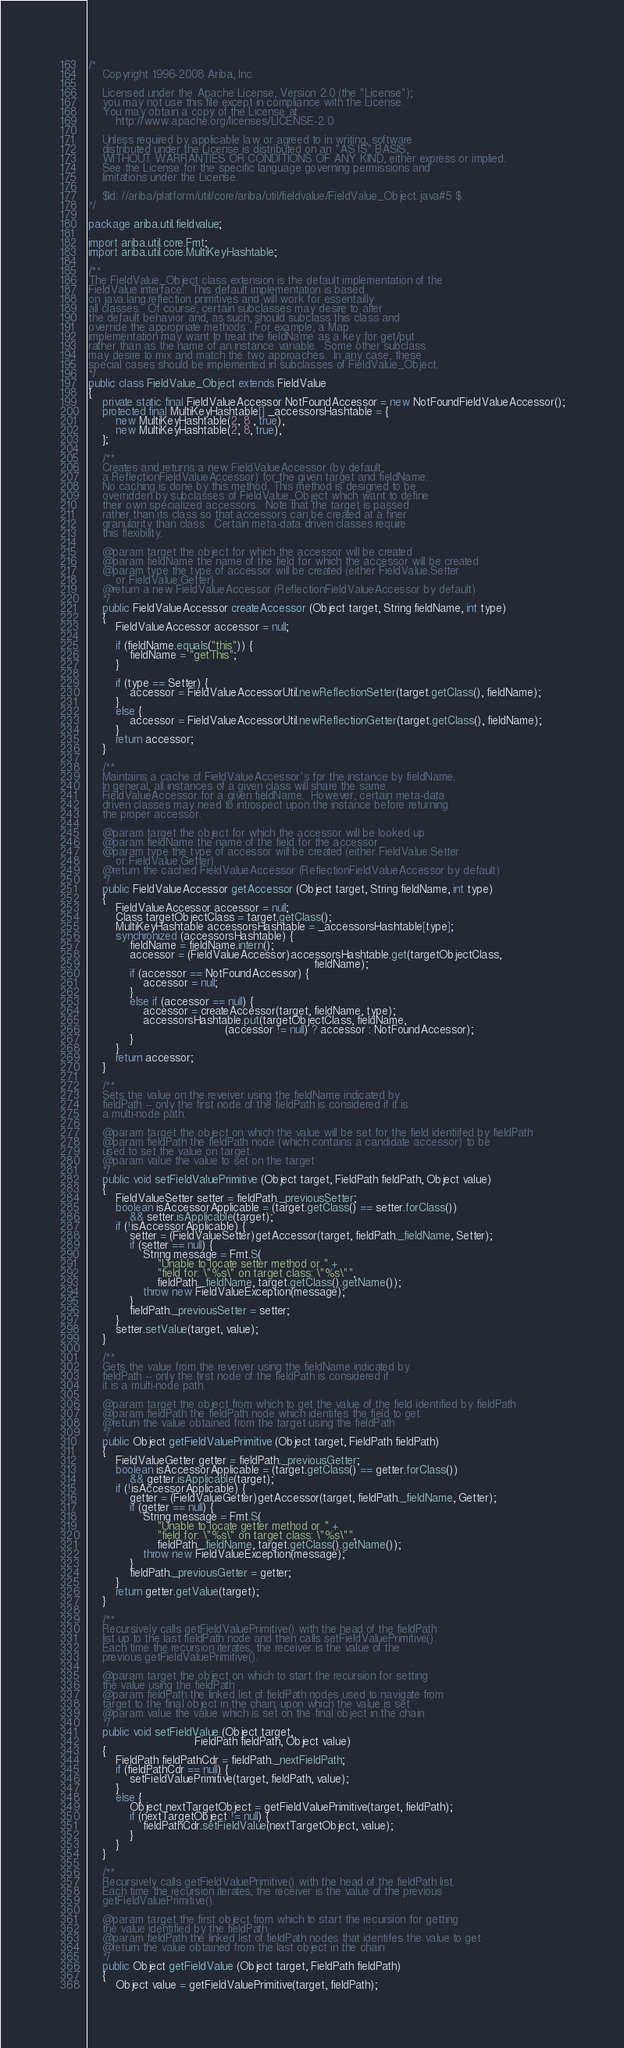<code> <loc_0><loc_0><loc_500><loc_500><_Java_>/*
    Copyright 1996-2008 Ariba, Inc.

    Licensed under the Apache License, Version 2.0 (the "License");
    you may not use this file except in compliance with the License.
    You may obtain a copy of the License at
        http://www.apache.org/licenses/LICENSE-2.0

    Unless required by applicable law or agreed to in writing, software
    distributed under the License is distributed on an "AS IS" BASIS,
    WITHOUT WARRANTIES OR CONDITIONS OF ANY KIND, either express or implied.
    See the License for the specific language governing permissions and
    limitations under the License.

    $Id: //ariba/platform/util/core/ariba/util/fieldvalue/FieldValue_Object.java#5 $
*/

package ariba.util.fieldvalue;

import ariba.util.core.Fmt;
import ariba.util.core.MultiKeyHashtable;

/**
The FieldValue_Object class extension is the default implementation of the
FieldValue interface.  This default implementation is based
on java.lang.reflection primitives and will work for essentailly
all classes.  Of course, certain subclasses may desire to alter
the default behavior and, as such, should subclass this class and
override the appropriate methods.  For example, a Map
implementation may want to treat the fieldName as a key for get/put
rather than as the name of an instance variable.  Some other subclass
may desire to mix and match the two approaches.  In any case, these
special cases should be implemented in subclasses of FieldValue_Object.
*/
public class FieldValue_Object extends FieldValue
{
    private static final FieldValueAccessor NotFoundAccessor = new NotFoundFieldValueAccessor();
    protected final MultiKeyHashtable[] _accessorsHashtable = {
        new MultiKeyHashtable(2, 8 , true),
        new MultiKeyHashtable(2, 8, true),
    };

    /**
    Creates and returns a new FieldValueAccessor (by default,
    a ReflectionFieldValueAccessor) for the given target and fieldName.
    No caching is done by this method. This method is designed to be
    overridden by subclasses of FieldValue_Object which want to define
    their own specialized accessors.  Note that the target is passed
    rather than its class so that accessors can be created at a finer
    granularity than class.  Certain meta-data driven classes require
    this flexibility.

    @param target the object for which the accessor will be created
    @param fieldName the name of the field for which the accessor will be created
    @param type the type of accessor will be created (either FieldValue.Setter
        or FieldValue.Getter)
    @return a new FieldValueAccessor (ReflectionFieldValueAccessor by default)
    */
    public FieldValueAccessor createAccessor (Object target, String fieldName, int type)
    {
        FieldValueAccessor accessor = null;

        if (fieldName.equals("this")) {
            fieldName = "getThis";
        }

        if (type == Setter) {
            accessor = FieldValueAccessorUtil.newReflectionSetter(target.getClass(), fieldName);
        }
        else {
            accessor = FieldValueAccessorUtil.newReflectionGetter(target.getClass(), fieldName);
        }
        return accessor;
    }

    /**
    Maintains a cache of FieldValueAccessor's for the instance by fieldName.
    In general, all instances of a given class will share the same
    FieldValueAccessor for a given fieldName.  However, certain meta-data
    driven classes may need to introspect upon the instance before returning
    the proper accessor.

    @param target the object for which the accessor will be looked up
    @param fieldName the name of the field for the accessor
    @param type the type of accessor will be created (either FieldValue.Setter
        or FieldValue.Getter)
    @return the cached FieldValueAccessor (ReflectionFieldValueAccessor by default)
    */
    public FieldValueAccessor getAccessor (Object target, String fieldName, int type)
    {
        FieldValueAccessor accessor = null;
        Class targetObjectClass = target.getClass();
        MultiKeyHashtable accessorsHashtable = _accessorsHashtable[type];
        synchronized (accessorsHashtable) {
            fieldName = fieldName.intern();
            accessor = (FieldValueAccessor)accessorsHashtable.get(targetObjectClass,
                                                                  fieldName);
            if (accessor == NotFoundAccessor) {
                accessor = null;
            }
            else if (accessor == null) {
                accessor = createAccessor(target, fieldName, type);
                accessorsHashtable.put(targetObjectClass, fieldName,
                                        (accessor != null) ? accessor : NotFoundAccessor);
            }
        }
        return accessor;
    }

    /**
    Sets the value on the reveiver using the fieldName indicated by
    fieldPath -- only the first node of the fieldPath is considered if it is
    a multi-node path.

    @param target the object on which the value will be set for the field identiifed by fieldPath
    @param fieldPath the fieldPath node (which contains a candidate accessor) to be
    used to set the value on target.
    @param value the value to set on the target
    */
    public void setFieldValuePrimitive (Object target, FieldPath fieldPath, Object value)
    {
        FieldValueSetter setter = fieldPath._previousSetter;
        boolean isAccessorApplicable = (target.getClass() == setter.forClass())
            && setter.isApplicable(target);
        if (!isAccessorApplicable) {
            setter = (FieldValueSetter)getAccessor(target, fieldPath._fieldName, Setter);
            if (setter == null) {
                String message = Fmt.S(
                    "Unable to locate setter method or " +
                    "field for: \"%s\" on target class: \"%s\"",
                    fieldPath._fieldName, target.getClass().getName());
                throw new FieldValueException(message);
            }
            fieldPath._previousSetter = setter;
        }
        setter.setValue(target, value);
    }

    /**
    Gets the value from the reveiver using the fieldName indicated by
    fieldPath -- only the first node of the fieldPath is considered if
    it is a multi-node path.

    @param target the object from which to get the value of the field identified by fieldPath
    @param fieldPath the fieldPath node which identifes the field to get.
    @return the value obtained from the target using the fieldPath
    */
    public Object getFieldValuePrimitive (Object target, FieldPath fieldPath)
    {
        FieldValueGetter getter = fieldPath._previousGetter;
        boolean isAccessorApplicable = (target.getClass() == getter.forClass())
            && getter.isApplicable(target);
        if (!isAccessorApplicable) {
            getter = (FieldValueGetter)getAccessor(target, fieldPath._fieldName, Getter);
            if (getter == null) {
                String message = Fmt.S(
                    "Unable to locate getter method or " +
                    "field for: \"%s\" on target class: \"%s\"",
                    fieldPath._fieldName, target.getClass().getName());
                throw new FieldValueException(message);
            }
            fieldPath._previousGetter = getter;
        }
        return getter.getValue(target);
    }

    /**
    Recursively calls getFieldValuePrimitive() with the head of the fieldPath
    list up to the last fieldPath node and then calls setFieldValuePrimitive().
    Each time the recursion iterates, the receiver is the value of the
    previous getFieldValuePrimitive().

    @param target the object on which to start the recursion for setting
    the value using the fieldPath
    @param fieldPath the linked list of fieldPath nodes used to navigate from
    target to the final object in the chain, upon which the value is set
    @param value the value which is set on the final object in the chain
    */
    public void setFieldValue (Object target,
                               FieldPath fieldPath, Object value)
    {
        FieldPath fieldPathCdr = fieldPath._nextFieldPath;
        if (fieldPathCdr == null) {
            setFieldValuePrimitive(target, fieldPath, value);
        }
        else {
            Object nextTargetObject = getFieldValuePrimitive(target, fieldPath);
            if (nextTargetObject != null) {
                fieldPathCdr.setFieldValue(nextTargetObject, value);
            }
        }
    }

    /**
    Recursively calls getFieldValuePrimitive() with the head of the fieldPath list.
    Each time the recursion iterates, the receiver is the value of the previous
    getFieldValuePrimitive().

    @param target the first object from which to start the recursion for getting
    the value identified by the fieldPath.
    @param fieldPath the linked list of fieldPath nodes that identifes the value to get
    @return the value obtained from the last object in the chain
    */
    public Object getFieldValue (Object target, FieldPath fieldPath)
    {
        Object value = getFieldValuePrimitive(target, fieldPath);</code> 